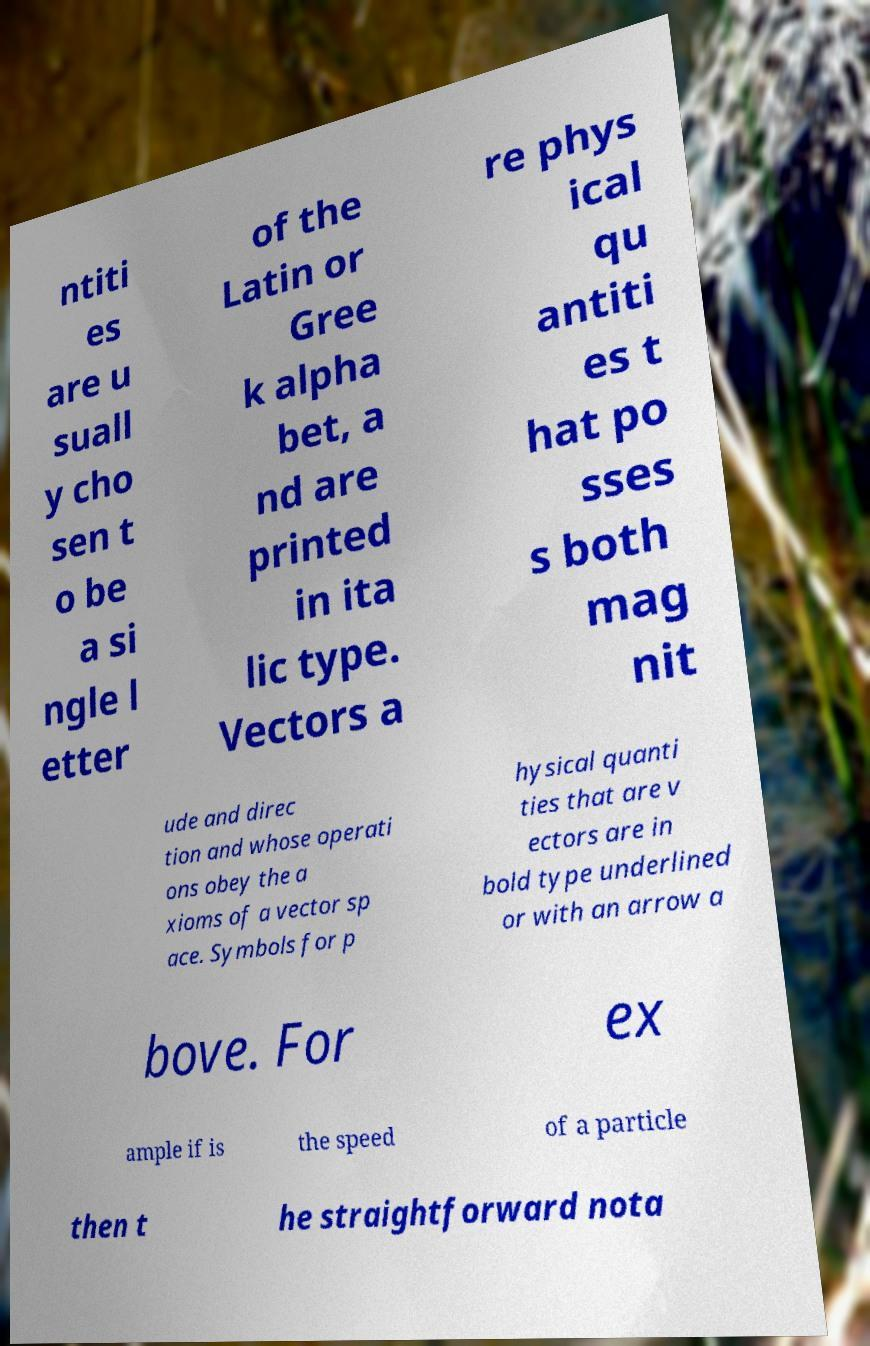For documentation purposes, I need the text within this image transcribed. Could you provide that? ntiti es are u suall y cho sen t o be a si ngle l etter of the Latin or Gree k alpha bet, a nd are printed in ita lic type. Vectors a re phys ical qu antiti es t hat po sses s both mag nit ude and direc tion and whose operati ons obey the a xioms of a vector sp ace. Symbols for p hysical quanti ties that are v ectors are in bold type underlined or with an arrow a bove. For ex ample if is the speed of a particle then t he straightforward nota 